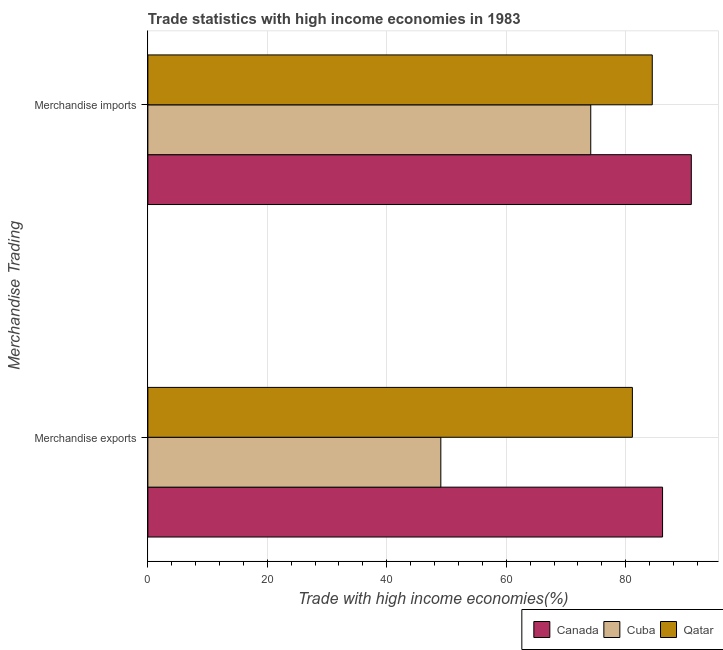Are the number of bars per tick equal to the number of legend labels?
Offer a very short reply. Yes. Are the number of bars on each tick of the Y-axis equal?
Ensure brevity in your answer.  Yes. How many bars are there on the 1st tick from the bottom?
Ensure brevity in your answer.  3. What is the label of the 2nd group of bars from the top?
Your answer should be compact. Merchandise exports. What is the merchandise exports in Qatar?
Provide a succinct answer. 81.12. Across all countries, what is the maximum merchandise imports?
Keep it short and to the point. 90.99. Across all countries, what is the minimum merchandise imports?
Your answer should be compact. 74.15. In which country was the merchandise exports maximum?
Give a very brief answer. Canada. In which country was the merchandise imports minimum?
Make the answer very short. Cuba. What is the total merchandise exports in the graph?
Provide a succinct answer. 216.35. What is the difference between the merchandise imports in Cuba and that in Qatar?
Your response must be concise. -10.3. What is the difference between the merchandise imports in Cuba and the merchandise exports in Qatar?
Your answer should be very brief. -6.97. What is the average merchandise imports per country?
Provide a short and direct response. 83.2. What is the difference between the merchandise exports and merchandise imports in Canada?
Your answer should be very brief. -4.82. What is the ratio of the merchandise imports in Cuba to that in Qatar?
Your answer should be compact. 0.88. Is the merchandise imports in Canada less than that in Cuba?
Your answer should be compact. No. In how many countries, is the merchandise exports greater than the average merchandise exports taken over all countries?
Your answer should be very brief. 2. What does the 1st bar from the top in Merchandise exports represents?
Provide a succinct answer. Qatar. What is the difference between two consecutive major ticks on the X-axis?
Ensure brevity in your answer.  20. Are the values on the major ticks of X-axis written in scientific E-notation?
Provide a succinct answer. No. Does the graph contain any zero values?
Your answer should be very brief. No. Does the graph contain grids?
Give a very brief answer. Yes. Where does the legend appear in the graph?
Provide a short and direct response. Bottom right. What is the title of the graph?
Provide a short and direct response. Trade statistics with high income economies in 1983. Does "Oman" appear as one of the legend labels in the graph?
Offer a terse response. No. What is the label or title of the X-axis?
Your answer should be very brief. Trade with high income economies(%). What is the label or title of the Y-axis?
Give a very brief answer. Merchandise Trading. What is the Trade with high income economies(%) of Canada in Merchandise exports?
Your answer should be very brief. 86.18. What is the Trade with high income economies(%) in Cuba in Merchandise exports?
Provide a succinct answer. 49.05. What is the Trade with high income economies(%) of Qatar in Merchandise exports?
Provide a succinct answer. 81.12. What is the Trade with high income economies(%) in Canada in Merchandise imports?
Make the answer very short. 90.99. What is the Trade with high income economies(%) in Cuba in Merchandise imports?
Your answer should be very brief. 74.15. What is the Trade with high income economies(%) of Qatar in Merchandise imports?
Give a very brief answer. 84.45. Across all Merchandise Trading, what is the maximum Trade with high income economies(%) of Canada?
Provide a short and direct response. 90.99. Across all Merchandise Trading, what is the maximum Trade with high income economies(%) of Cuba?
Offer a very short reply. 74.15. Across all Merchandise Trading, what is the maximum Trade with high income economies(%) of Qatar?
Your response must be concise. 84.45. Across all Merchandise Trading, what is the minimum Trade with high income economies(%) of Canada?
Ensure brevity in your answer.  86.18. Across all Merchandise Trading, what is the minimum Trade with high income economies(%) of Cuba?
Your answer should be very brief. 49.05. Across all Merchandise Trading, what is the minimum Trade with high income economies(%) of Qatar?
Your answer should be very brief. 81.12. What is the total Trade with high income economies(%) in Canada in the graph?
Give a very brief answer. 177.17. What is the total Trade with high income economies(%) of Cuba in the graph?
Your response must be concise. 123.2. What is the total Trade with high income economies(%) of Qatar in the graph?
Your response must be concise. 165.58. What is the difference between the Trade with high income economies(%) of Canada in Merchandise exports and that in Merchandise imports?
Offer a very short reply. -4.82. What is the difference between the Trade with high income economies(%) in Cuba in Merchandise exports and that in Merchandise imports?
Ensure brevity in your answer.  -25.1. What is the difference between the Trade with high income economies(%) in Qatar in Merchandise exports and that in Merchandise imports?
Provide a succinct answer. -3.33. What is the difference between the Trade with high income economies(%) in Canada in Merchandise exports and the Trade with high income economies(%) in Cuba in Merchandise imports?
Provide a succinct answer. 12.02. What is the difference between the Trade with high income economies(%) of Canada in Merchandise exports and the Trade with high income economies(%) of Qatar in Merchandise imports?
Keep it short and to the point. 1.72. What is the difference between the Trade with high income economies(%) of Cuba in Merchandise exports and the Trade with high income economies(%) of Qatar in Merchandise imports?
Offer a terse response. -35.4. What is the average Trade with high income economies(%) in Canada per Merchandise Trading?
Make the answer very short. 88.58. What is the average Trade with high income economies(%) of Cuba per Merchandise Trading?
Offer a very short reply. 61.6. What is the average Trade with high income economies(%) in Qatar per Merchandise Trading?
Offer a very short reply. 82.79. What is the difference between the Trade with high income economies(%) of Canada and Trade with high income economies(%) of Cuba in Merchandise exports?
Ensure brevity in your answer.  37.12. What is the difference between the Trade with high income economies(%) of Canada and Trade with high income economies(%) of Qatar in Merchandise exports?
Offer a very short reply. 5.05. What is the difference between the Trade with high income economies(%) in Cuba and Trade with high income economies(%) in Qatar in Merchandise exports?
Give a very brief answer. -32.07. What is the difference between the Trade with high income economies(%) in Canada and Trade with high income economies(%) in Cuba in Merchandise imports?
Keep it short and to the point. 16.84. What is the difference between the Trade with high income economies(%) of Canada and Trade with high income economies(%) of Qatar in Merchandise imports?
Provide a succinct answer. 6.54. What is the ratio of the Trade with high income economies(%) in Canada in Merchandise exports to that in Merchandise imports?
Offer a terse response. 0.95. What is the ratio of the Trade with high income economies(%) of Cuba in Merchandise exports to that in Merchandise imports?
Your answer should be compact. 0.66. What is the ratio of the Trade with high income economies(%) in Qatar in Merchandise exports to that in Merchandise imports?
Your response must be concise. 0.96. What is the difference between the highest and the second highest Trade with high income economies(%) of Canada?
Keep it short and to the point. 4.82. What is the difference between the highest and the second highest Trade with high income economies(%) of Cuba?
Your answer should be compact. 25.1. What is the difference between the highest and the second highest Trade with high income economies(%) in Qatar?
Your response must be concise. 3.33. What is the difference between the highest and the lowest Trade with high income economies(%) of Canada?
Give a very brief answer. 4.82. What is the difference between the highest and the lowest Trade with high income economies(%) in Cuba?
Give a very brief answer. 25.1. What is the difference between the highest and the lowest Trade with high income economies(%) in Qatar?
Make the answer very short. 3.33. 